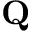<formula> <loc_0><loc_0><loc_500><loc_500>Q</formula> 